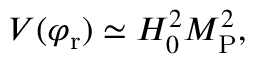<formula> <loc_0><loc_0><loc_500><loc_500>V ( \varphi _ { r } ) \simeq H _ { 0 } ^ { 2 } M _ { P } ^ { 2 } ,</formula> 